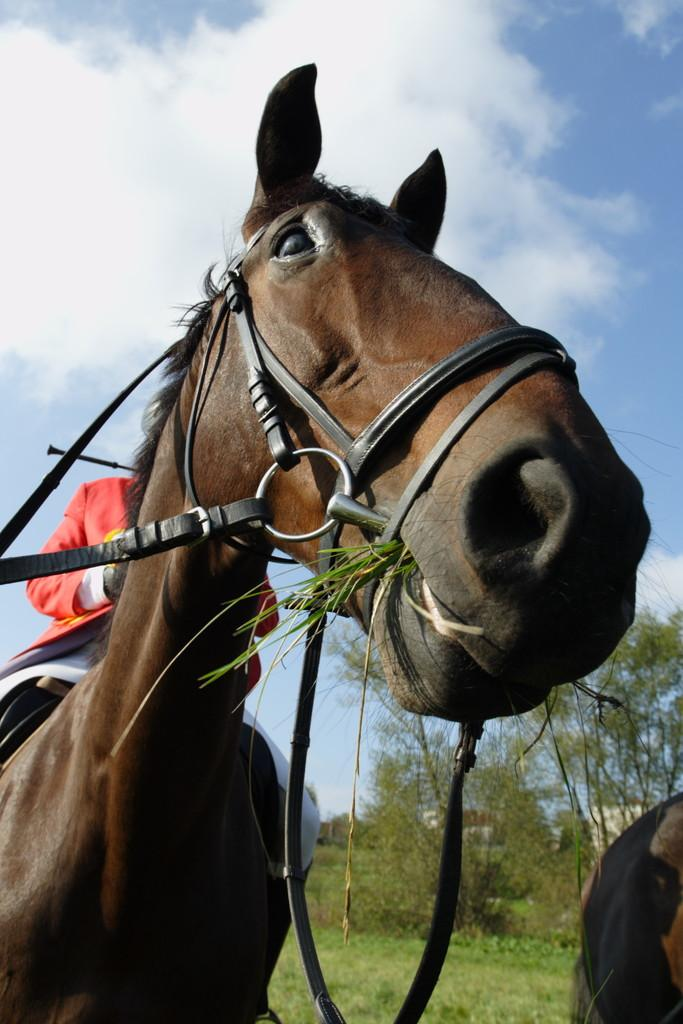What is the main subject of the image? There is a person sitting on a horse in the image. Are there any other horses in the image? Yes, there is another horse on the right side of the image. What can be seen in the background of the image? Plants are visible in the background of the image. How would you describe the weather in the image? The sky is clear in the image, suggesting good weather. What design is featured on the caption of the image? There is no caption present in the image, so it is not possible to determine the design. 